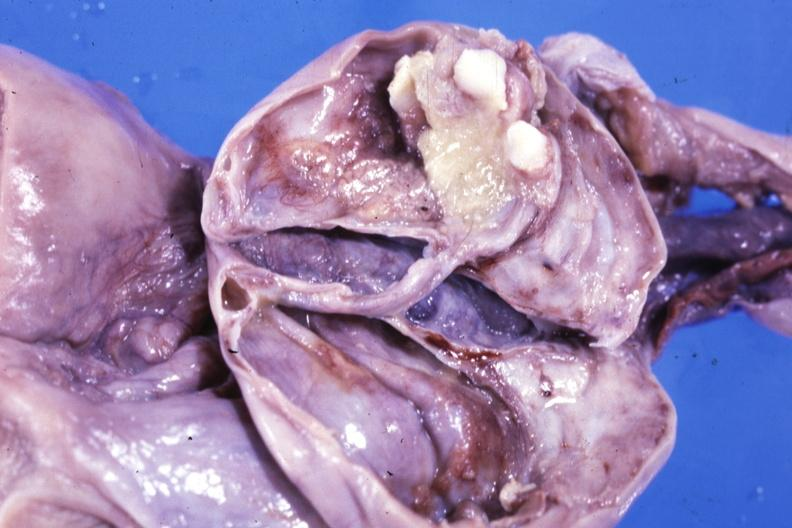s female reproductive present?
Answer the question using a single word or phrase. Yes 